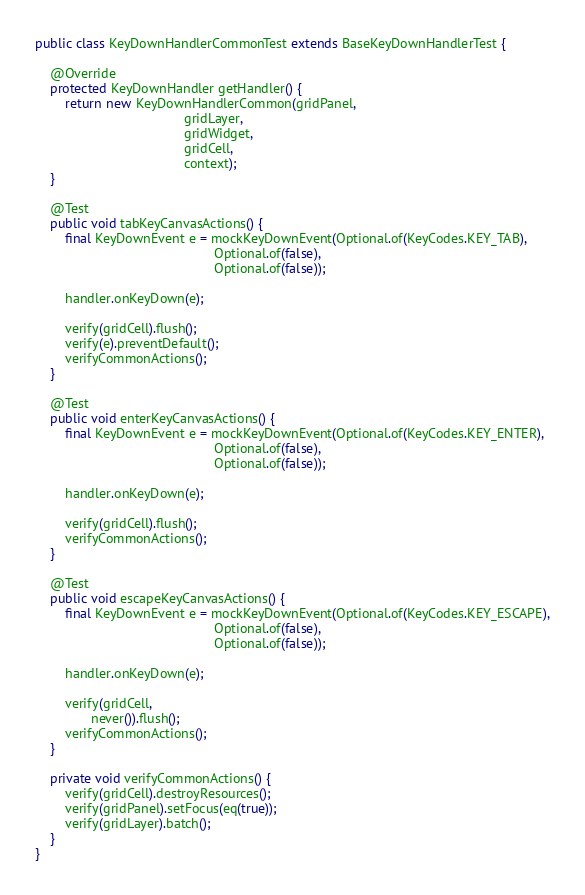Convert code to text. <code><loc_0><loc_0><loc_500><loc_500><_Java_>public class KeyDownHandlerCommonTest extends BaseKeyDownHandlerTest {

    @Override
    protected KeyDownHandler getHandler() {
        return new KeyDownHandlerCommon(gridPanel,
                                        gridLayer,
                                        gridWidget,
                                        gridCell,
                                        context);
    }

    @Test
    public void tabKeyCanvasActions() {
        final KeyDownEvent e = mockKeyDownEvent(Optional.of(KeyCodes.KEY_TAB),
                                                Optional.of(false),
                                                Optional.of(false));

        handler.onKeyDown(e);

        verify(gridCell).flush();
        verify(e).preventDefault();
        verifyCommonActions();
    }

    @Test
    public void enterKeyCanvasActions() {
        final KeyDownEvent e = mockKeyDownEvent(Optional.of(KeyCodes.KEY_ENTER),
                                                Optional.of(false),
                                                Optional.of(false));

        handler.onKeyDown(e);

        verify(gridCell).flush();
        verifyCommonActions();
    }

    @Test
    public void escapeKeyCanvasActions() {
        final KeyDownEvent e = mockKeyDownEvent(Optional.of(KeyCodes.KEY_ESCAPE),
                                                Optional.of(false),
                                                Optional.of(false));

        handler.onKeyDown(e);

        verify(gridCell,
               never()).flush();
        verifyCommonActions();
    }

    private void verifyCommonActions() {
        verify(gridCell).destroyResources();
        verify(gridPanel).setFocus(eq(true));
        verify(gridLayer).batch();
    }
}
</code> 